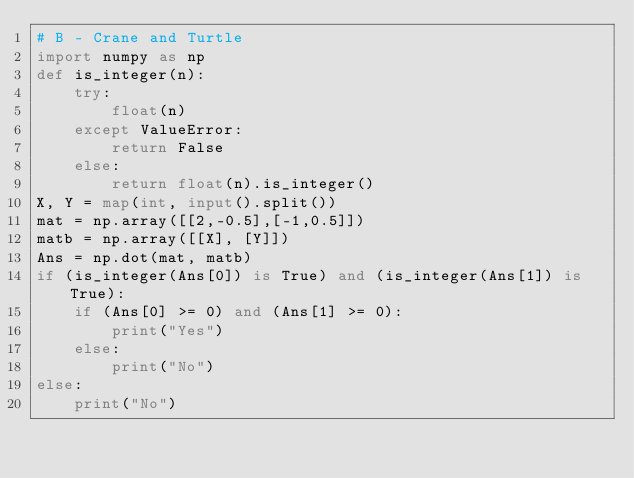<code> <loc_0><loc_0><loc_500><loc_500><_Python_># B - Crane and Turtle
import numpy as np
def is_integer(n):
    try:
        float(n)
    except ValueError:
        return False
    else:
        return float(n).is_integer()
X, Y = map(int, input().split())    
mat = np.array([[2,-0.5],[-1,0.5]])
matb = np.array([[X], [Y]])
Ans = np.dot(mat, matb)
if (is_integer(Ans[0]) is True) and (is_integer(Ans[1]) is True):
    if (Ans[0] >= 0) and (Ans[1] >= 0):
        print("Yes")
    else:
        print("No")
else:
    print("No")</code> 